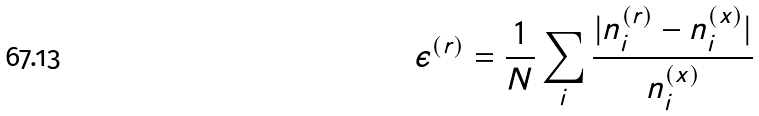Convert formula to latex. <formula><loc_0><loc_0><loc_500><loc_500>\epsilon ^ { ( r ) } = \frac { 1 } { N } \sum _ { i } \frac { | n _ { i } ^ { ( r ) } - n _ { i } ^ { ( x ) } | } { n _ { i } ^ { ( x ) } }</formula> 